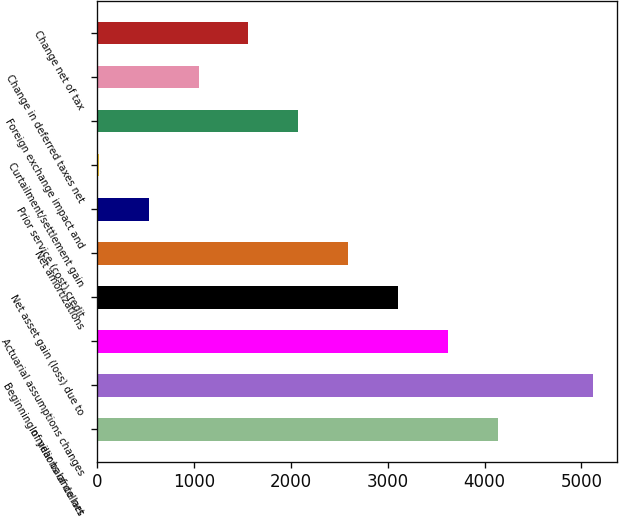<chart> <loc_0><loc_0><loc_500><loc_500><bar_chart><fcel>In millions of dollars<fcel>Beginning of year balance net<fcel>Actuarial assumptions changes<fcel>Net asset gain (loss) due to<fcel>Net amortizations<fcel>Prior service (cost) credit<fcel>Curtailment/settlement gain<fcel>Foreign exchange impact and<fcel>Change in deferred taxes net<fcel>Change net of tax<nl><fcel>4134.6<fcel>5116<fcel>3619.9<fcel>3105.2<fcel>2590.5<fcel>531.7<fcel>17<fcel>2075.8<fcel>1046.4<fcel>1561.1<nl></chart> 